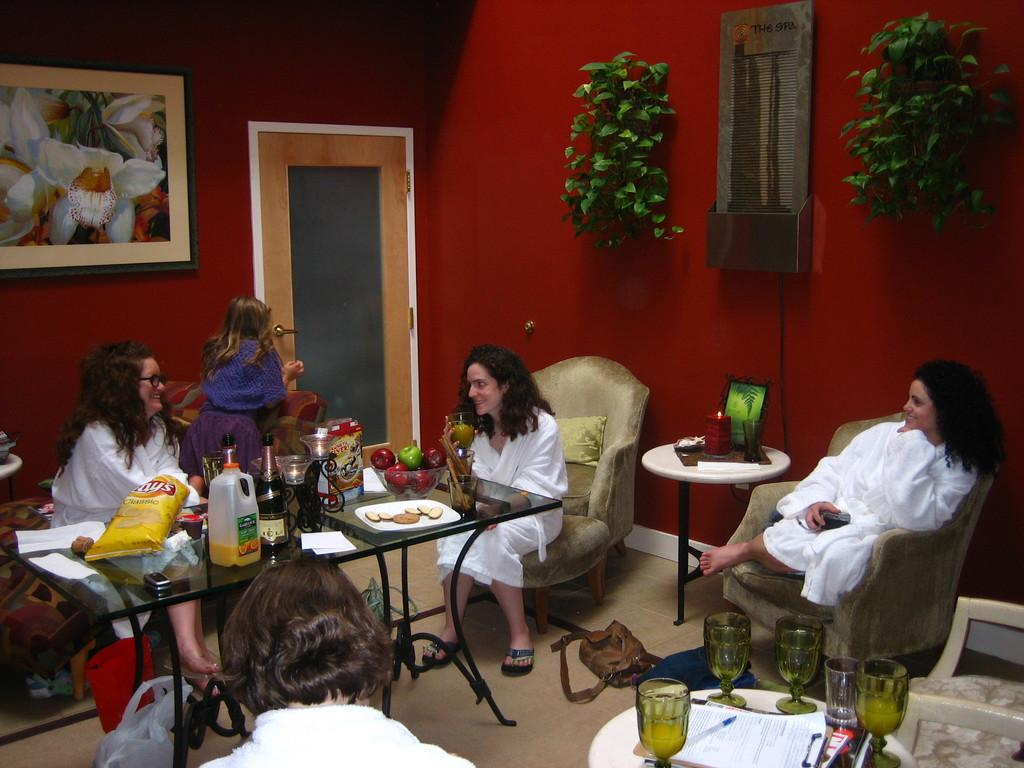What are the women in the image doing? The women in the image are sitting and smiling. What is in front of the women? There is a table in front of the women. Can you describe the person sitting in the image? The person sitting in the image is not specified, but we know there is at least one person present. What color is the wall in the image? The wall in the image is red. What other objects can be seen in the image? There is a plant and a photo frame in the image. What flavor of fruit is the lawyer holding in the image? There is no lawyer or fruit present in the image. 